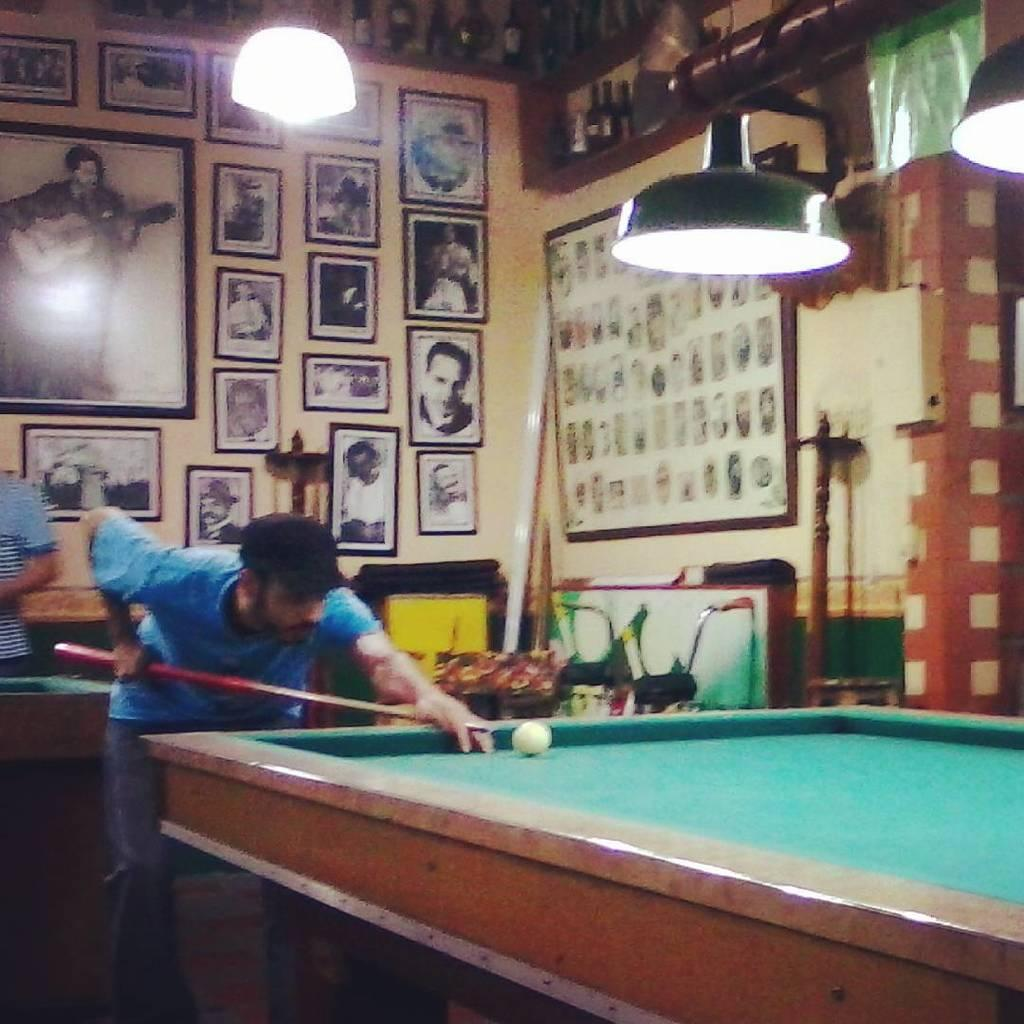What is the person in the image doing? The person is playing a game. What object is the person holding in his hand? The person is holding a stick in his hand. What can be seen on the wall behind the person? There are many photo frames on the wall behind him. What type of crime is being committed in the image? There is no crime being committed in the image; the person is simply playing a game. What kind of stone is present in the image? There is no stone present in the image. 